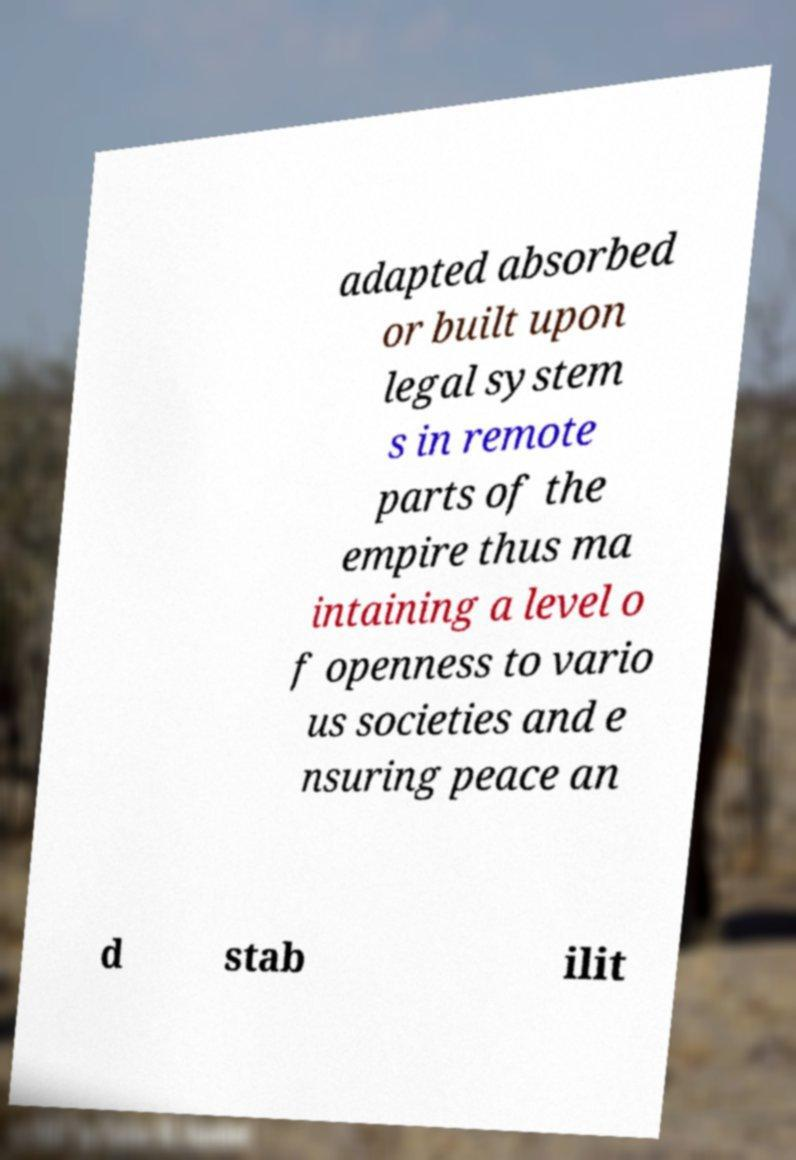For documentation purposes, I need the text within this image transcribed. Could you provide that? adapted absorbed or built upon legal system s in remote parts of the empire thus ma intaining a level o f openness to vario us societies and e nsuring peace an d stab ilit 